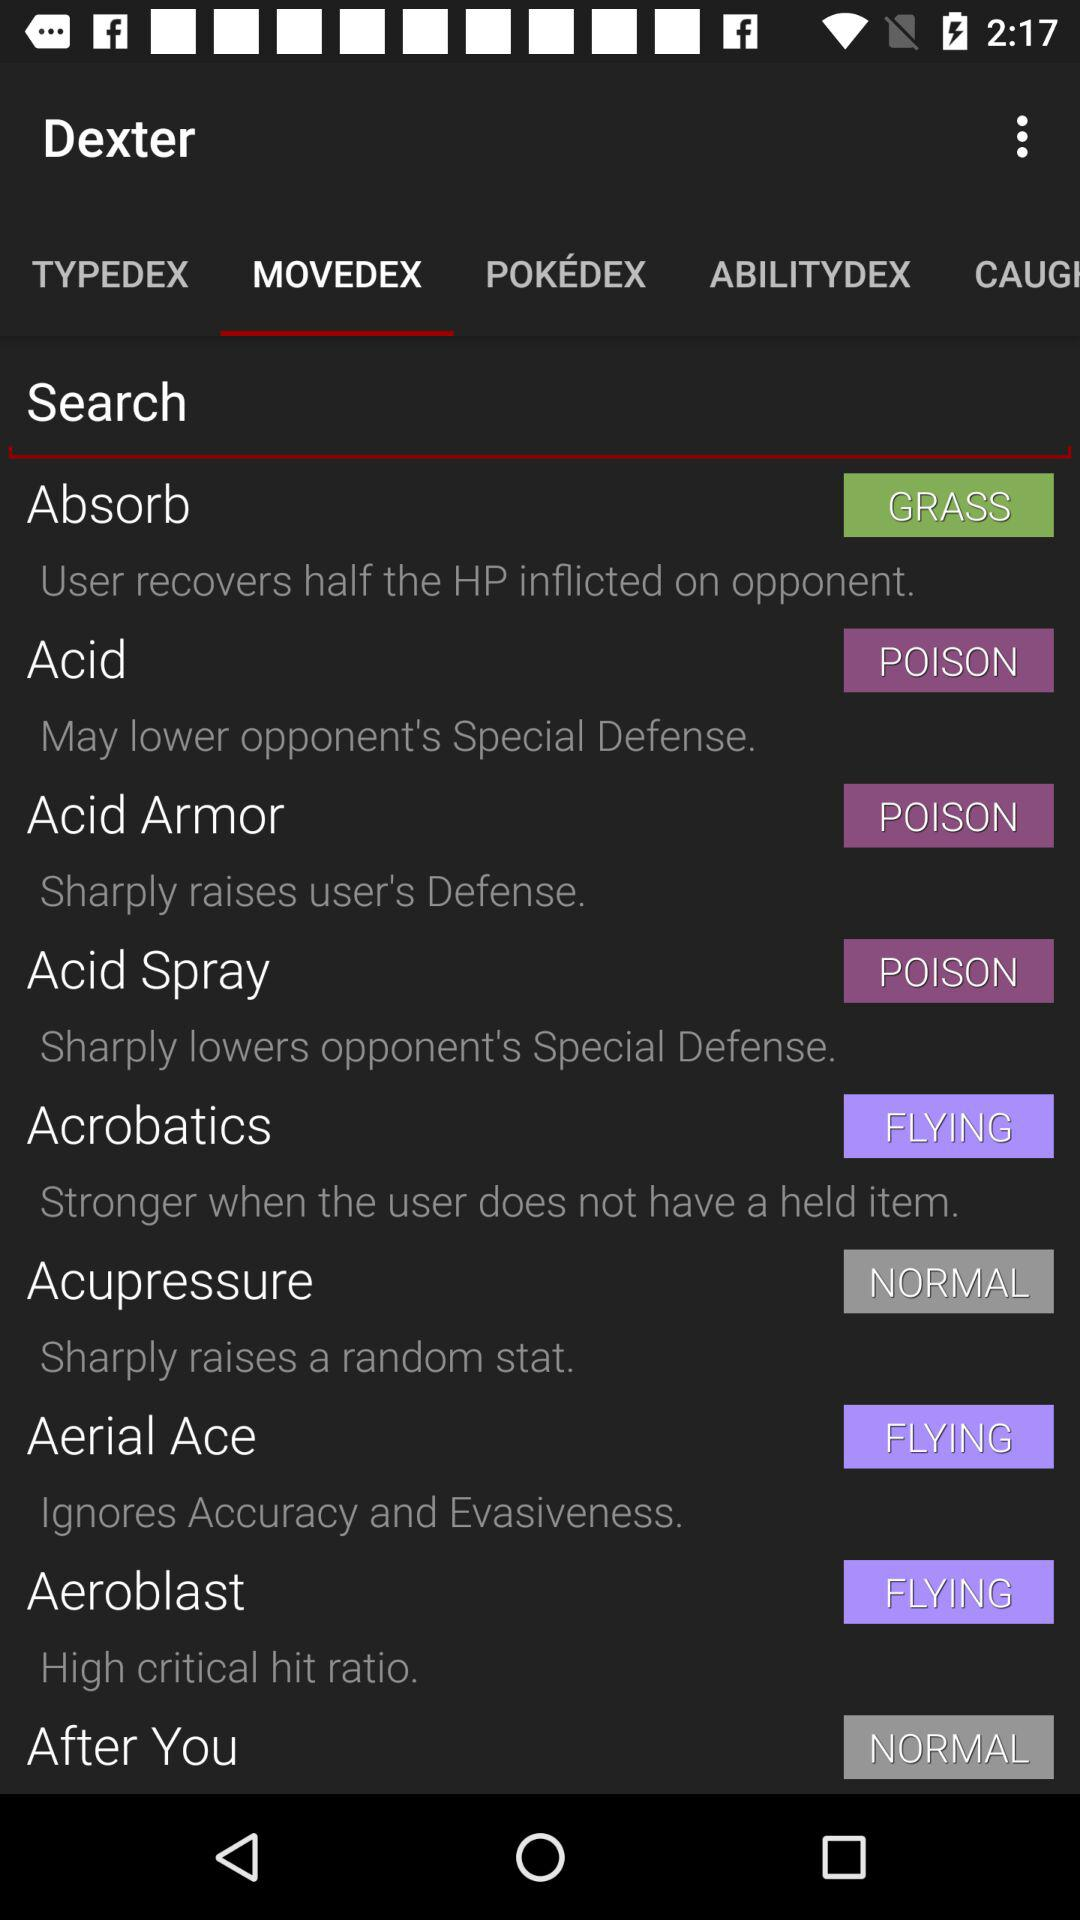What is the description of the "Absorb"? The description of the "Absorb" is "User recovers half the HP inflicted on opponent". 